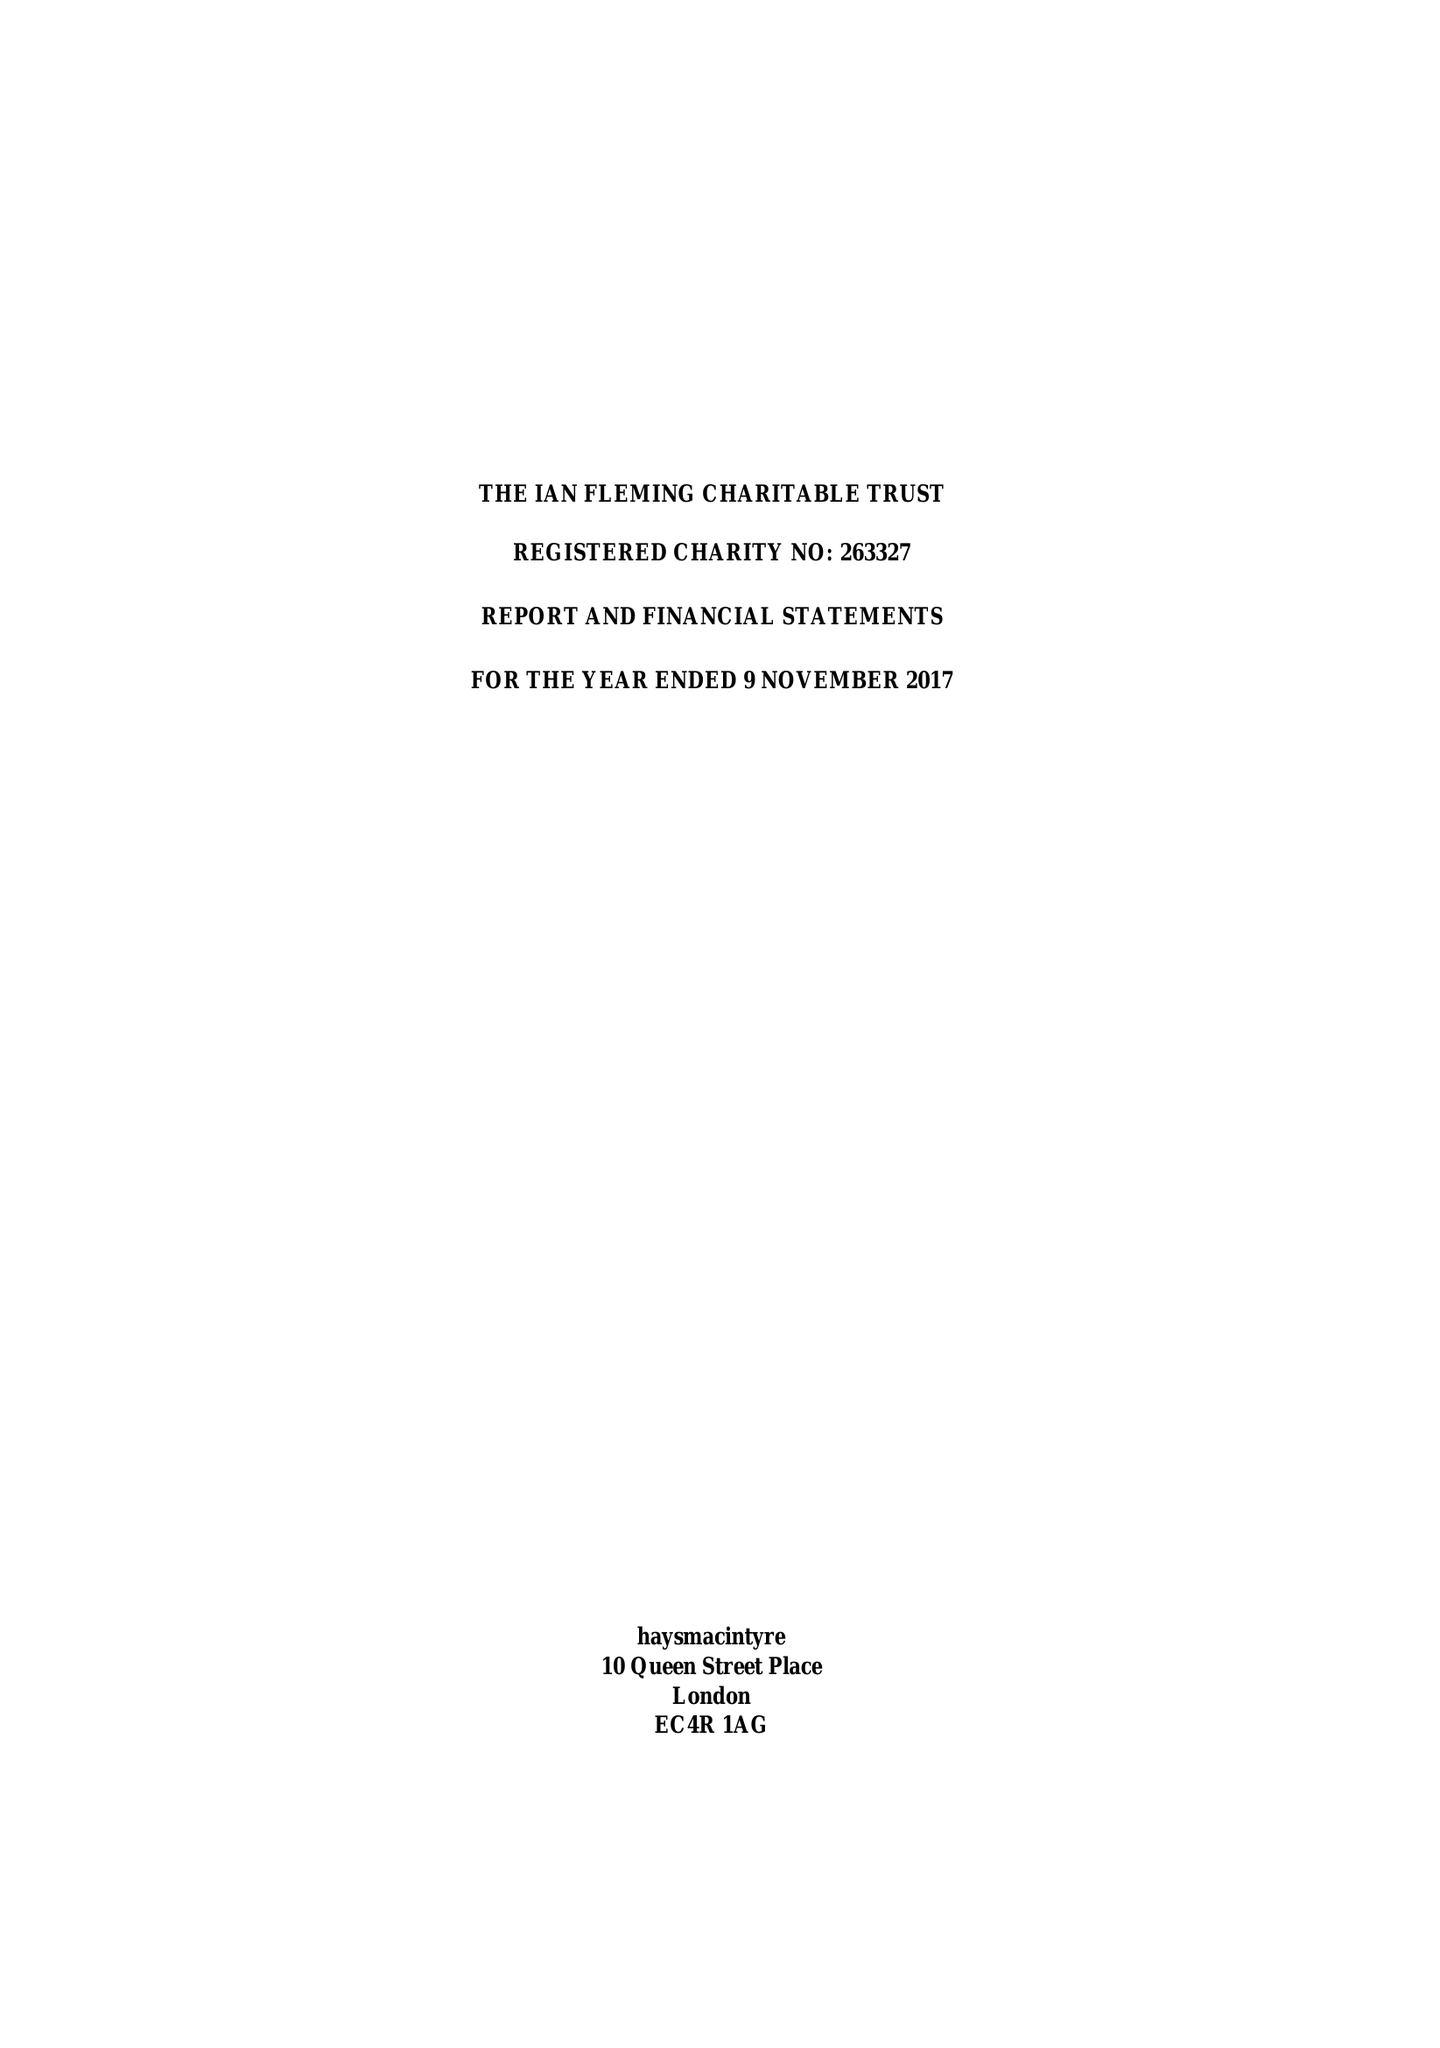What is the value for the spending_annually_in_british_pounds?
Answer the question using a single word or phrase. 117629.00 